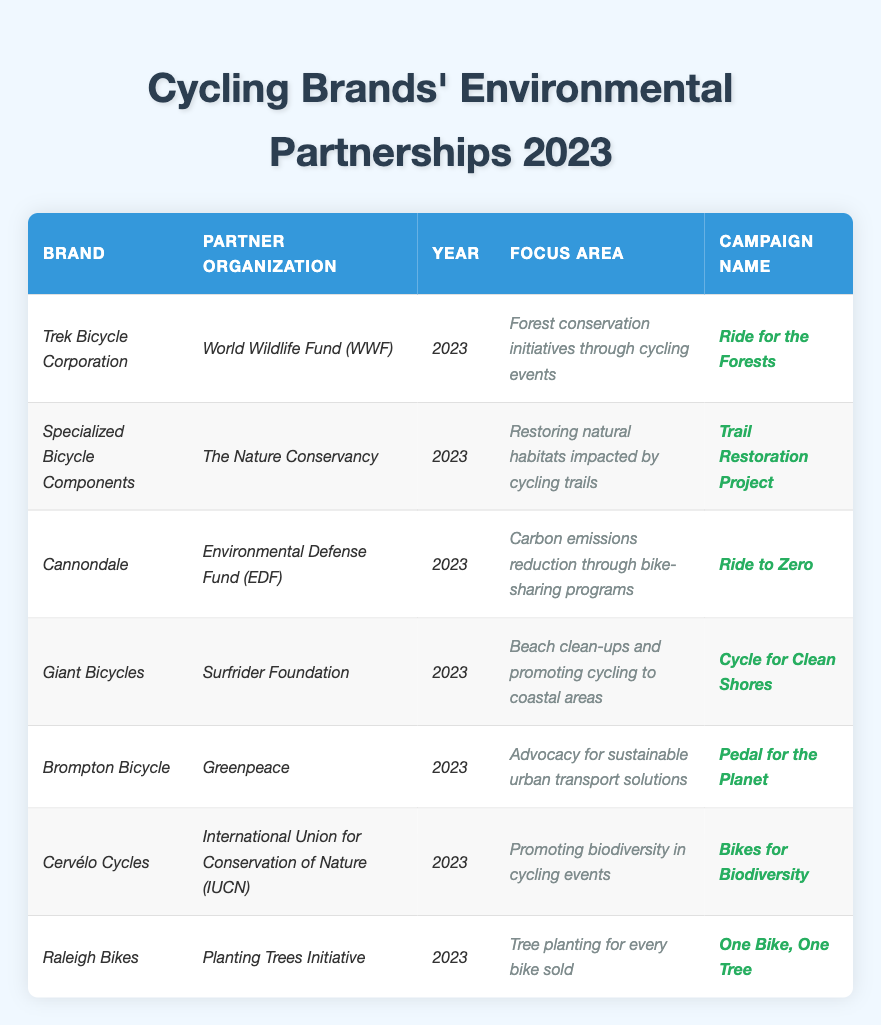What cycling brand partnered with the World Wildlife Fund (WWF)? The table lists "Trek Bicycle Corporation" as the brand that established a partnership with the "World Wildlife Fund (WWF)" in 2023.
Answer: Trek Bicycle Corporation Which campaign focuses on tree planting for every bike sold? The table shows that "Raleigh Bikes" has a campaign named "One Bike, One Tree," which focuses on tree planting for every bike sold.
Answer: One Bike, One Tree How many brands established partnerships in 2023? There are 7 entries in the table, indicating that 7 brands established partnerships in the year 2023.
Answer: 7 What is the focus area of the campaign "Cycle for Clean Shores"? According to the table, the focus area for the "Cycle for Clean Shores" campaign, associated with "Giant Bicycles," is beach clean-ups and promoting cycling to coastal areas.
Answer: Beach clean-ups and promoting cycling to coastal areas Is there any brand that collaborates with Greenpeace? "Brompton Bicycle" is listed in the table as the brand that collaborates with Greenpeace.
Answer: Yes Which brand has the focus area related to carbon emissions reduction? The brand "Cannondale" is associated with the focus area of carbon emissions reduction through bike-sharing programs.
Answer: Cannondale Can you list all the organizations partnered with cycling brands? By reviewing the table, the partner organizations include WWF, The Nature Conservancy, EDF, Surfrider Foundation, Greenpeace, IUCN, and the Planting Trees Initiative.
Answer: WWF, The Nature Conservancy, EDF, Surfrider Foundation, Greenpeace, IUCN, Planting Trees Initiative Which focus area is related to cycling trails? The table indicates that "Restoring natural habitats impacted by cycling trails" is the focus area of "Specialized Bicycle Components."
Answer: Restoring natural habitats impacted by cycling trails What are the names of the campaigns focused on biodiversity? The table lists "Bikes for Biodiversity" from Cervélo Cycles as the campaign that focuses on promoting biodiversity.
Answer: Bikes for Biodiversity Which brand's campaign advocates for sustainable urban transport solutions? "Brompton Bicycle" has the campaign "Pedal for the Planet," which advocates for sustainable urban transport solutions, as noted in the table.
Answer: Brompton Bicycle What is the focus area associated with the "Ride to Zero" campaign? The focus area for the "Ride to Zero" campaign is carbon emissions reduction through bike-sharing programs, which is linked to Cannondale according to the table.
Answer: Carbon emissions reduction through bike-sharing programs 